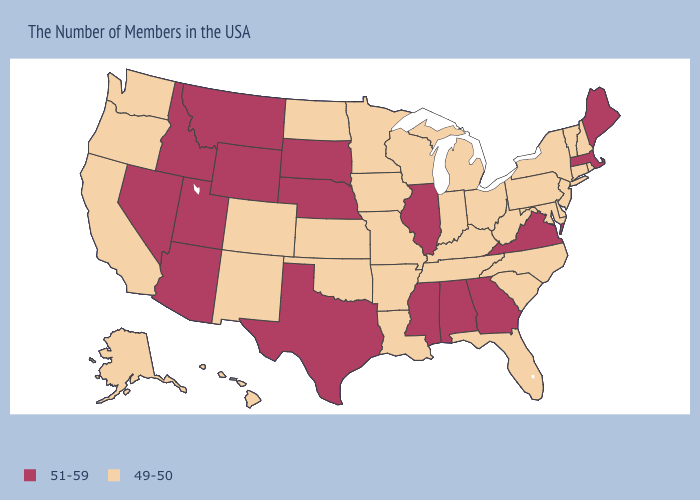Does Oklahoma have the same value as Mississippi?
Give a very brief answer. No. Name the states that have a value in the range 49-50?
Keep it brief. Rhode Island, New Hampshire, Vermont, Connecticut, New York, New Jersey, Delaware, Maryland, Pennsylvania, North Carolina, South Carolina, West Virginia, Ohio, Florida, Michigan, Kentucky, Indiana, Tennessee, Wisconsin, Louisiana, Missouri, Arkansas, Minnesota, Iowa, Kansas, Oklahoma, North Dakota, Colorado, New Mexico, California, Washington, Oregon, Alaska, Hawaii. Is the legend a continuous bar?
Quick response, please. No. Name the states that have a value in the range 49-50?
Concise answer only. Rhode Island, New Hampshire, Vermont, Connecticut, New York, New Jersey, Delaware, Maryland, Pennsylvania, North Carolina, South Carolina, West Virginia, Ohio, Florida, Michigan, Kentucky, Indiana, Tennessee, Wisconsin, Louisiana, Missouri, Arkansas, Minnesota, Iowa, Kansas, Oklahoma, North Dakota, Colorado, New Mexico, California, Washington, Oregon, Alaska, Hawaii. What is the value of Connecticut?
Answer briefly. 49-50. Does the first symbol in the legend represent the smallest category?
Give a very brief answer. No. Name the states that have a value in the range 51-59?
Answer briefly. Maine, Massachusetts, Virginia, Georgia, Alabama, Illinois, Mississippi, Nebraska, Texas, South Dakota, Wyoming, Utah, Montana, Arizona, Idaho, Nevada. Does Pennsylvania have the highest value in the USA?
Short answer required. No. Does Michigan have the lowest value in the MidWest?
Short answer required. Yes. What is the value of Maine?
Give a very brief answer. 51-59. Name the states that have a value in the range 51-59?
Quick response, please. Maine, Massachusetts, Virginia, Georgia, Alabama, Illinois, Mississippi, Nebraska, Texas, South Dakota, Wyoming, Utah, Montana, Arizona, Idaho, Nevada. What is the value of Georgia?
Quick response, please. 51-59. Does the first symbol in the legend represent the smallest category?
Be succinct. No. Which states have the lowest value in the West?
Be succinct. Colorado, New Mexico, California, Washington, Oregon, Alaska, Hawaii. 